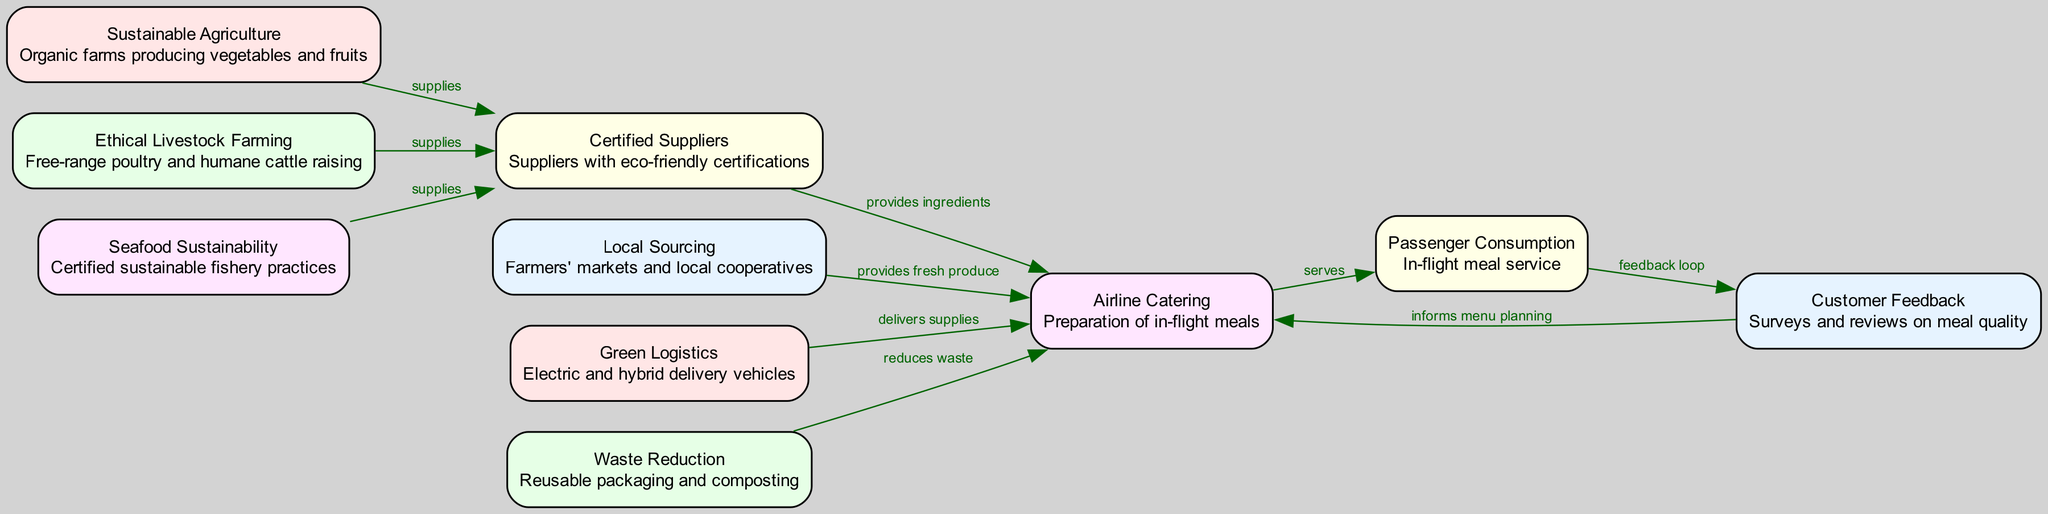What are the node labels in the diagram? The diagram contains nodes with the following labels: Sustainable Agriculture, Ethical Livestock Farming, Seafood Sustainability, Certified Suppliers, Local Sourcing, Green Logistics, Waste Reduction, Airline Catering, Passenger Consumption, Customer Feedback.
Answer: Sustainable Agriculture, Ethical Livestock Farming, Seafood Sustainability, Certified Suppliers, Local Sourcing, Green Logistics, Waste Reduction, Airline Catering, Passenger Consumption, Customer Feedback How many nodes are in the diagram? Upon reviewing the diagram, there are 10 distinct nodes representing different elements of the food supply chain.
Answer: 10 Which node primarily focuses on the preparation of in-flight meals? By examining the nodes, "Airline Catering" is specifically designated for the preparation of in-flight meals.
Answer: Airline Catering What is the relationship between Local Sourcing and Airline Catering? The relationship shows that Local Sourcing "provides fresh produce" to Airline Catering, indicating that fresh produce from local markets is essential for meal preparation.
Answer: Provides fresh produce Which two nodes directly provide supplies to Certified Suppliers? Both Sustainable Agriculture and Ethical Livestock Farming provide supplies to Certified Suppliers, indicating that these practices contribute to certified sourcing.
Answer: Sustainable Agriculture, Ethical Livestock Farming How does Customer Feedback influence menu planning? Customer Feedback creates a feedback loop with Airline Catering that informs menu planning, meaning the feedback received from passengers is used to plan future meal options.
Answer: Informs menu planning What is the role of Green Logistics in the supply chain? Green Logistics is responsible for delivering supplies to Airline Catering using eco-friendly methods, emphasizing sustainable transport in the supply chain.
Answer: Delivers supplies Name one method used in Waste Reduction. Waste Reduction employs "Reusable packaging and composting" to minimize waste effectively within the food supply chain.
Answer: Reusable packaging and composting How many edges connect to Airline Catering? Upon review, there are 4 edges connecting to the Airline Catering node, indicating multiple relationships with other elements in the supply chain.
Answer: 4 What type of suppliers are linked to Seafood Sustainability? Seafood Sustainability is linked to Certified Suppliers, indicating that sustainable fishery practices are supplied by certified sources.
Answer: Certified Suppliers 